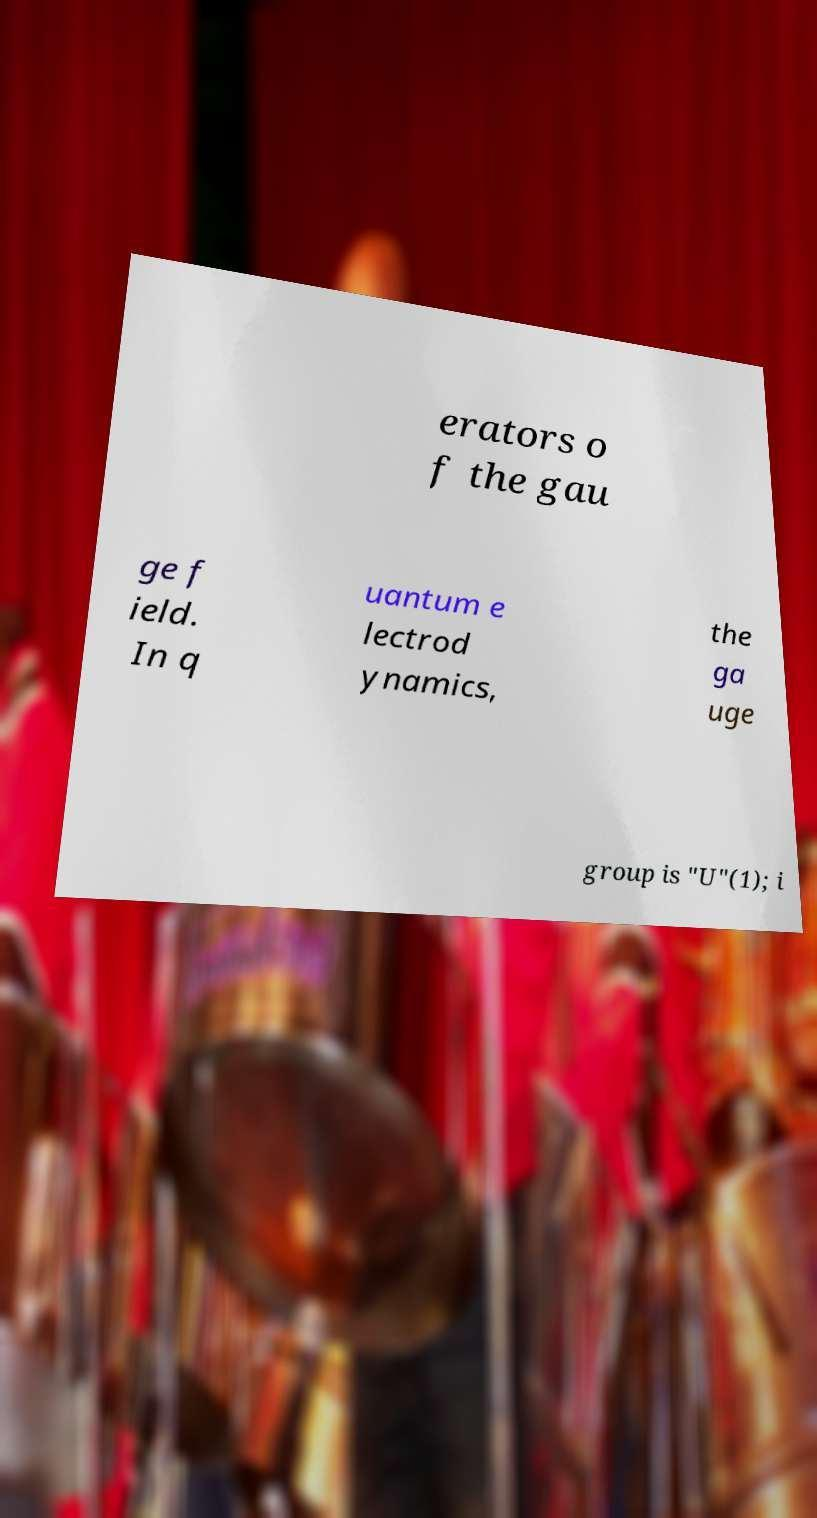There's text embedded in this image that I need extracted. Can you transcribe it verbatim? erators o f the gau ge f ield. In q uantum e lectrod ynamics, the ga uge group is "U"(1); i 